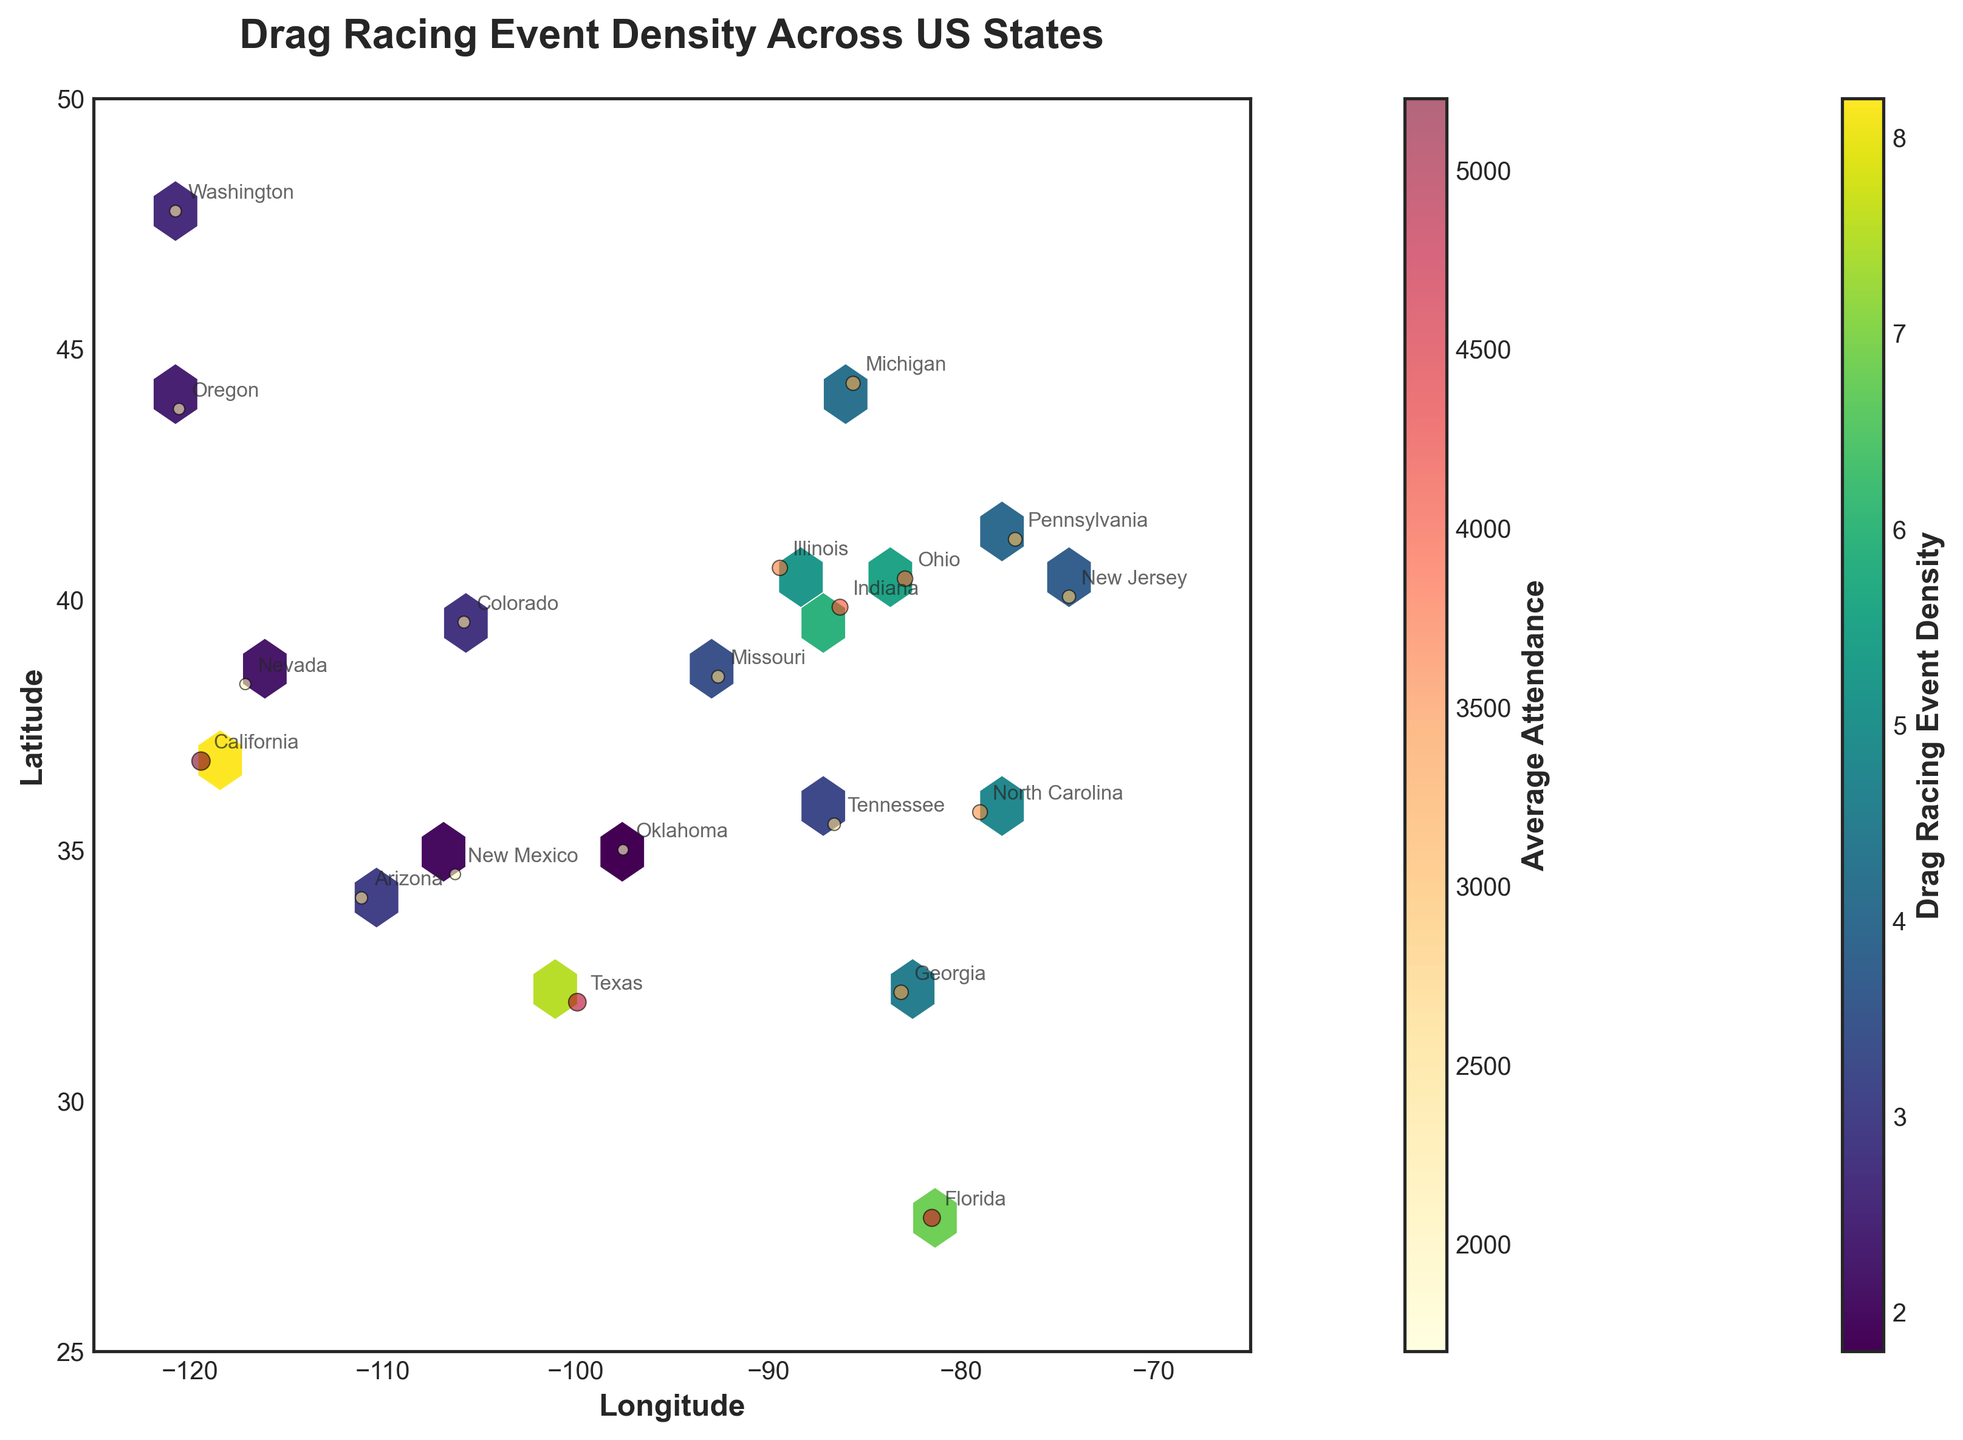what is the title of the figure? The title of the figure is located at the top center of the plot. It reads "Drag Racing Event Density Across US States".
Answer: Drag Racing Event Density Across US States What do the colors in the hexagon bins represent? The colors in the hexagon bins represent the density of drag racing events. The color mapping is shown in the color bar to the right, labeled "Drag Racing Event Density".
Answer: Density of drag racing events Which state has the highest density of drag racing events? The color of the hexbin for California is the darkest among all, indicating the highest density value.
Answer: California What's the range of the latitude shown in the plot? The y-axis indicates latitude. The range starts from 25 and goes up to 50 as marked on the y-axis.
Answer: 25 to 50 Which state has the second highest average attendance of drag racing events? By observing the scatter plot with color coding, Texas has the second-largest marker indicating average attendance just after California.
Answer: Texas How does the average attendance in Florida compare with that in Indiana? The scatter plot shows Florida's marker at an average attendance of 4500, while Indiana's is lower at 3900, indicated by the relative sizes and colors of their markers.
Answer: Florida has higher attendance than Indiana What does a darker hexbin and a larger scatter marker indicate about a state's drag racing events? A darker hexbin indicates a higher density of drag racing events, and a larger scatter marker indicates a higher average attendance at these events.
Answer: Higher density and higher average attendance How do the densities of drag racing events for New Jersey and Arizona compare? The hexbin for New Jersey is slightly darker than Arizona's, which implies a higher density for New Jersey even though both are in lighter color tones.
Answer: New Jersey has a higher density What are the parameters shown on the x and y-axis, and what do they represent? The x-axis represents the longitude and the y-axis represents the latitude. These parameters show the geographic locations of states within the US on the plot.
Answer: Longitude and Latitude Which region appears to have the overall highest density of drag racing events? According to the concentration and darkness of multiple hexbins, the Western and Southwestern regions, including California, have overall higher densities.
Answer: Western and Southwestern regions 